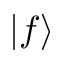<formula> <loc_0><loc_0><loc_500><loc_500>| f \rangle</formula> 